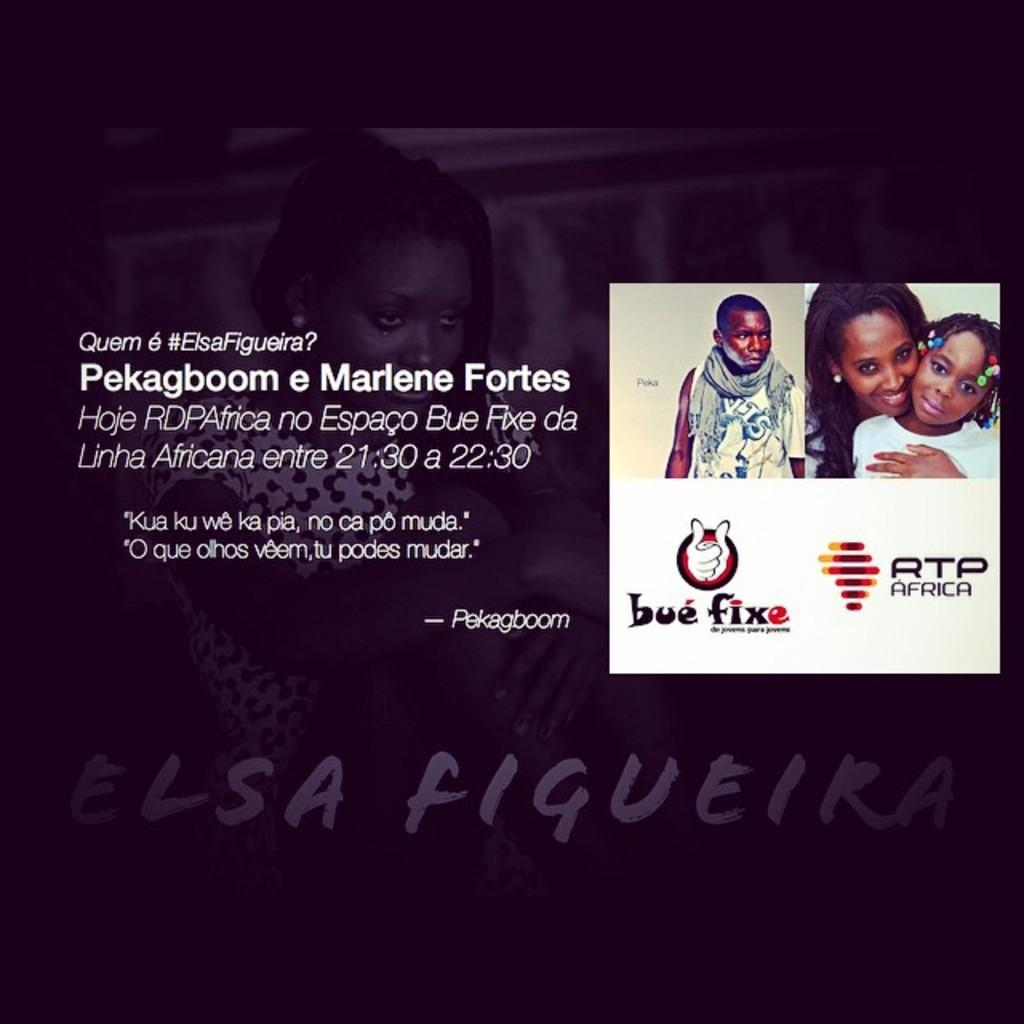What can be found in the image that contains written words? There is text in the image. What else can be seen in the image along with the text? There are humans with a logo in the image. Can you describe the setting of the image? There is a woman in the background of the image. Are there any other written words visible in the image? Yes, there is additional text in the background of the image. What type of brush is being used by the woman in the image? There is no brush visible in the image; the woman is in the background, and no specific activity is described. Is the porter mentioned or depicted in the image? There is no mention or depiction of a porter in the image. 